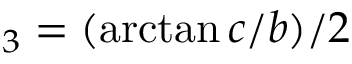<formula> <loc_0><loc_0><loc_500><loc_500>_ { 3 } = ( \arctan c / b ) / 2</formula> 